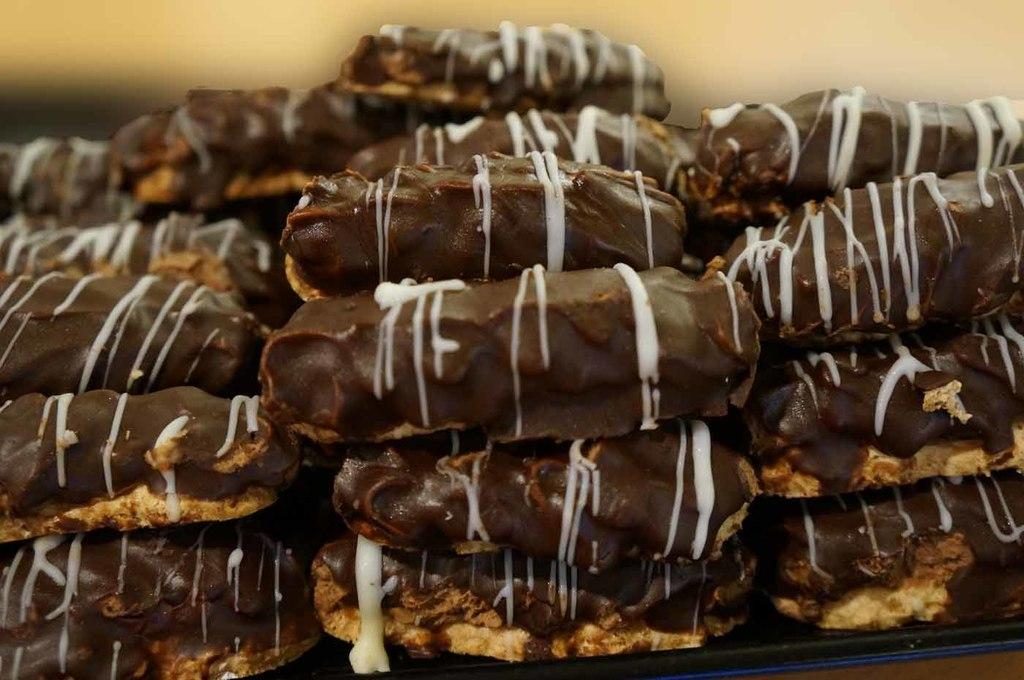What is the main subject of the image? The main subject of the image is a tray with food arranged on it. How is the food in the tray decorated or enhanced? The food is sprinkled with white cream. What grade does the passenger give to the food served on the plane in the image? There is no plane, passenger, or grade present in the image; it only features a tray with food arranged on it and sprinkled with white cream. 